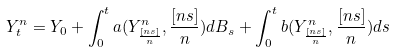Convert formula to latex. <formula><loc_0><loc_0><loc_500><loc_500>Y _ { t } ^ { n } = Y _ { 0 } + \int _ { 0 } ^ { t } a ( Y _ { \frac { [ n s ] } { n } } ^ { n } , \frac { [ n s ] } { n } ) d B _ { s } + \int _ { 0 } ^ { t } b ( Y _ { \frac { [ n s ] } { n } } ^ { n } , \frac { [ n s ] } { n } ) d s</formula> 